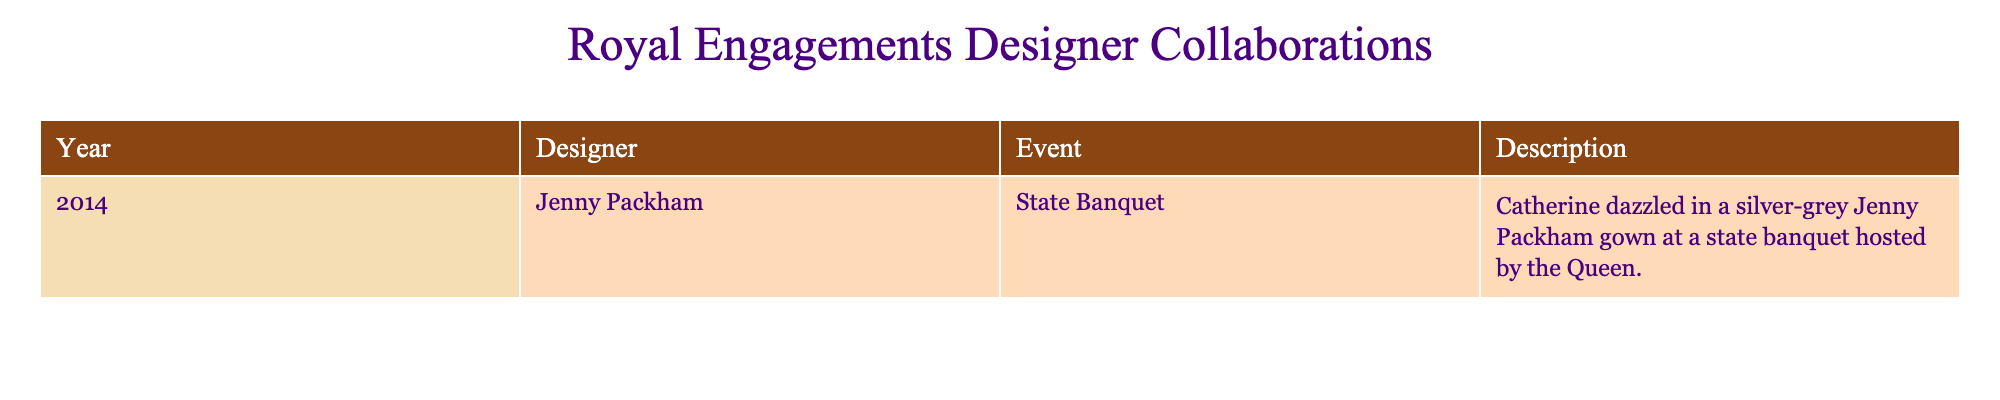What year did Catherine wear a Jenny Packham gown? The table lists a specific event in 2014 where Catherine wore a Jenny Packham gown.
Answer: 2014 What event is described for the designer collaboration in 2014? The table specifies that the event is a state banquet hosted by the Queen in 2014.
Answer: State Banquet Which designer collaborated with the royal family in 2014? According to the table, Jenny Packham is the designer collaborating in the year 2014.
Answer: Jenny Packham Was the gown worn by Catherine at the state banquet described as silver-grey? The description in the table clearly states that the gown was silver-grey.
Answer: Yes How many designer collaborations for royal engagements are listed in the table? The table contains only one entry, indicating that there is one designer collaboration.
Answer: 1 What color was Catherine's gown during the state banquet in 2014? The table states that Catherine's gown was a silver-grey color during the event.
Answer: Silver-grey If Jenny Packham was the only designer mentioned, how many different designers collaborated on royal engagements in this table? There's only one entry in the table, which lists Jenny Packham as the designer, indicating no variety.
Answer: 1 Was there any collaboration mentioned for royal engagements before 2014 in this table? The table contains only data for 2014, thus no earlier collaborations are noted.
Answer: No Which year shows the designer Jenny Packham working with the royal family? Can you list more years associated with this designer in the table? The table shows Jenny Packham collaborating in the year 2014, and no other years are present in the current dataset.
Answer: 2014 What can be inferred about the trend of designer collaborations for royal engagements from the table provided? With only one collaboration listed from 2014, we cannot infer a trend accurately; more data would be needed to establish any trends.
Answer: No trend can be inferred 